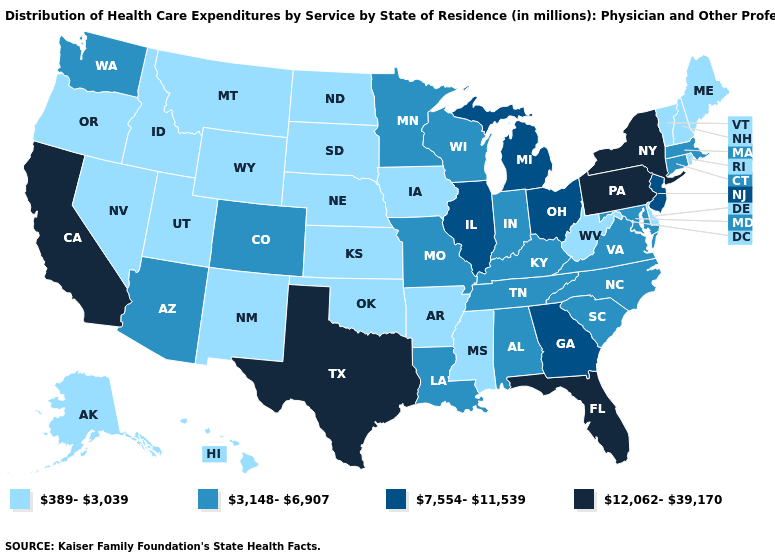Does the map have missing data?
Answer briefly. No. Name the states that have a value in the range 3,148-6,907?
Answer briefly. Alabama, Arizona, Colorado, Connecticut, Indiana, Kentucky, Louisiana, Maryland, Massachusetts, Minnesota, Missouri, North Carolina, South Carolina, Tennessee, Virginia, Washington, Wisconsin. What is the value of North Dakota?
Short answer required. 389-3,039. Does Rhode Island have the same value as Washington?
Quick response, please. No. Name the states that have a value in the range 3,148-6,907?
Quick response, please. Alabama, Arizona, Colorado, Connecticut, Indiana, Kentucky, Louisiana, Maryland, Massachusetts, Minnesota, Missouri, North Carolina, South Carolina, Tennessee, Virginia, Washington, Wisconsin. Name the states that have a value in the range 3,148-6,907?
Be succinct. Alabama, Arizona, Colorado, Connecticut, Indiana, Kentucky, Louisiana, Maryland, Massachusetts, Minnesota, Missouri, North Carolina, South Carolina, Tennessee, Virginia, Washington, Wisconsin. What is the lowest value in the MidWest?
Quick response, please. 389-3,039. What is the value of Texas?
Short answer required. 12,062-39,170. What is the value of New Jersey?
Give a very brief answer. 7,554-11,539. What is the lowest value in states that border Minnesota?
Quick response, please. 389-3,039. Name the states that have a value in the range 3,148-6,907?
Concise answer only. Alabama, Arizona, Colorado, Connecticut, Indiana, Kentucky, Louisiana, Maryland, Massachusetts, Minnesota, Missouri, North Carolina, South Carolina, Tennessee, Virginia, Washington, Wisconsin. Does West Virginia have the lowest value in the USA?
Give a very brief answer. Yes. How many symbols are there in the legend?
Write a very short answer. 4. What is the lowest value in the West?
Be succinct. 389-3,039. Which states have the lowest value in the USA?
Quick response, please. Alaska, Arkansas, Delaware, Hawaii, Idaho, Iowa, Kansas, Maine, Mississippi, Montana, Nebraska, Nevada, New Hampshire, New Mexico, North Dakota, Oklahoma, Oregon, Rhode Island, South Dakota, Utah, Vermont, West Virginia, Wyoming. 